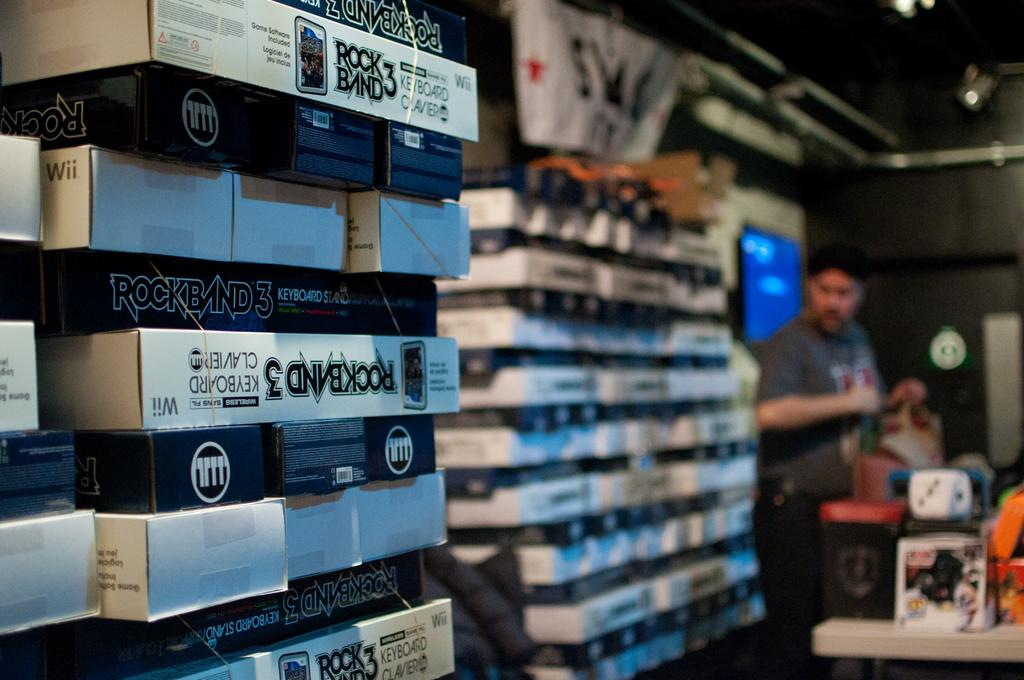<image>
Share a concise interpretation of the image provided. Items on a rack in a store for the game rock band 3 